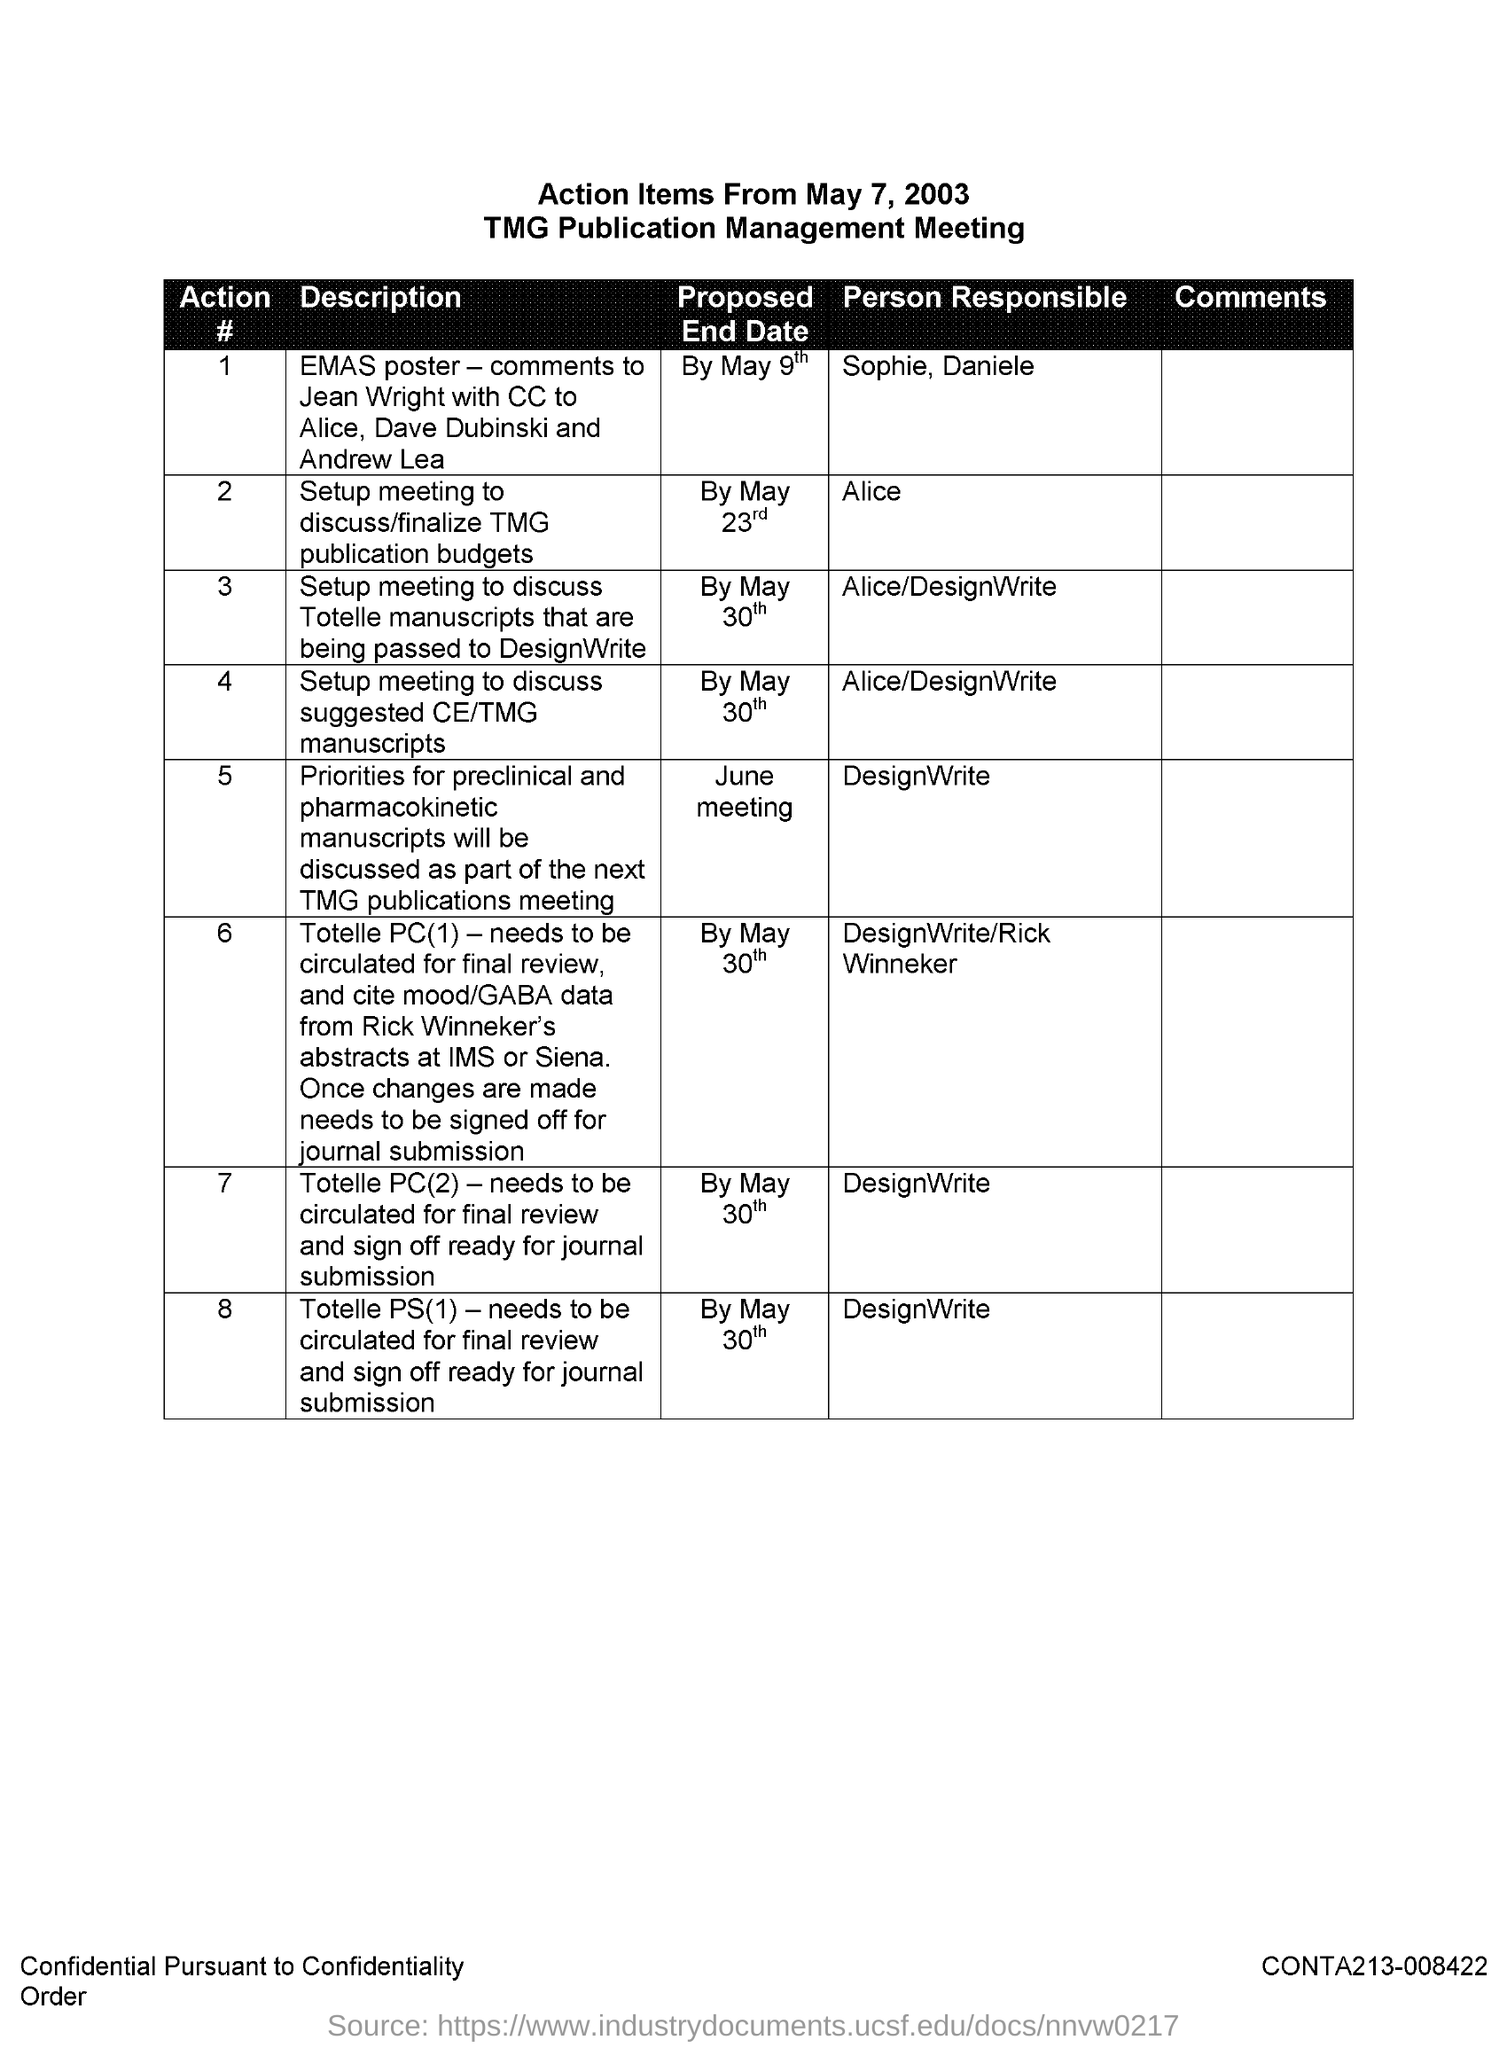What is the first title in the document?
Keep it short and to the point. Action Items From May 7, 2003. What is the second title in the document?
Make the answer very short. TMG Publication Management Meeting. Who is responsible for action # 2?
Provide a succinct answer. Alice. Who is responsible for action # 8?
Keep it short and to the point. DesignWrite. What is the Proposed End date of Action # 4?
Offer a very short reply. By May 30th. 